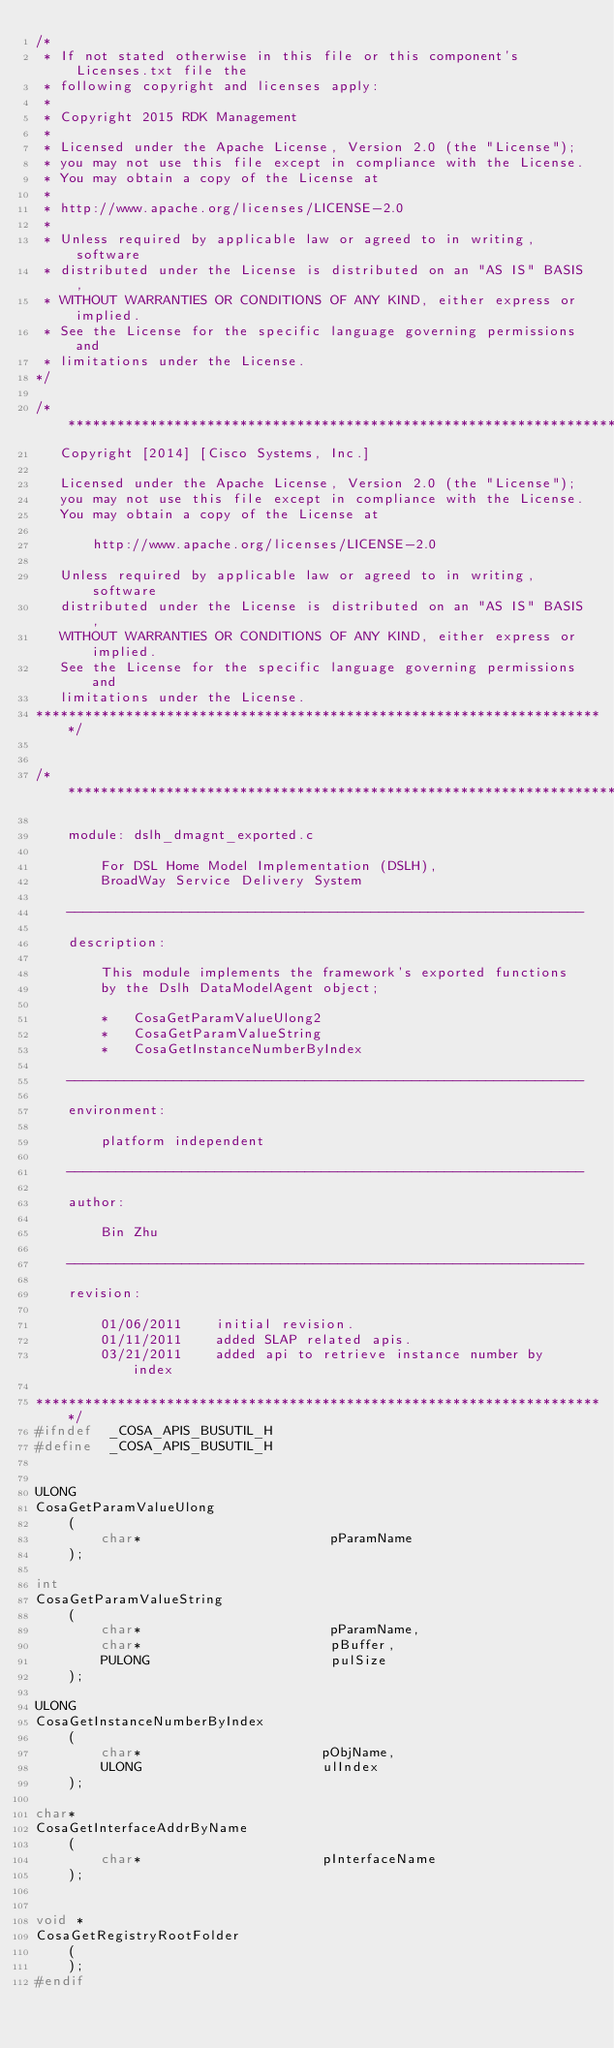Convert code to text. <code><loc_0><loc_0><loc_500><loc_500><_C_>/*
 * If not stated otherwise in this file or this component's Licenses.txt file the
 * following copyright and licenses apply:
 *
 * Copyright 2015 RDK Management
 *
 * Licensed under the Apache License, Version 2.0 (the "License");
 * you may not use this file except in compliance with the License.
 * You may obtain a copy of the License at
 *
 * http://www.apache.org/licenses/LICENSE-2.0
 *
 * Unless required by applicable law or agreed to in writing, software
 * distributed under the License is distributed on an "AS IS" BASIS,
 * WITHOUT WARRANTIES OR CONDITIONS OF ANY KIND, either express or implied.
 * See the License for the specific language governing permissions and
 * limitations under the License.
*/

/**********************************************************************
   Copyright [2014] [Cisco Systems, Inc.]
 
   Licensed under the Apache License, Version 2.0 (the "License");
   you may not use this file except in compliance with the License.
   You may obtain a copy of the License at
 
       http://www.apache.org/licenses/LICENSE-2.0
 
   Unless required by applicable law or agreed to in writing, software
   distributed under the License is distributed on an "AS IS" BASIS,
   WITHOUT WARRANTIES OR CONDITIONS OF ANY KIND, either express or implied.
   See the License for the specific language governing permissions and
   limitations under the License.
**********************************************************************/


/**********************************************************************

    module: dslh_dmagnt_exported.c

        For DSL Home Model Implementation (DSLH),
        BroadWay Service Delivery System

    ---------------------------------------------------------------

    description:

        This module implements the framework's exported functions
        by the Dslh DataModelAgent object;

        *   CosaGetParamValueUlong2
        *   CosaGetParamValueString
        *   CosaGetInstanceNumberByIndex

    ---------------------------------------------------------------

    environment:

        platform independent

    ---------------------------------------------------------------

    author:

        Bin Zhu

    ---------------------------------------------------------------

    revision:

        01/06/2011    initial revision.
        01/11/2011    added SLAP related apis.
        03/21/2011    added api to retrieve instance number by index

**********************************************************************/
#ifndef  _COSA_APIS_BUSUTIL_H
#define  _COSA_APIS_BUSUTIL_H


ULONG
CosaGetParamValueUlong
    (
        char*                       pParamName
    );

int
CosaGetParamValueString
    (
        char*                       pParamName,
        char*                       pBuffer,
        PULONG                      pulSize
    );

ULONG
CosaGetInstanceNumberByIndex
    (
        char*                      pObjName,
        ULONG                      ulIndex
    );

char*
CosaGetInterfaceAddrByName
    (
        char*                      pInterfaceName
    );


void *
CosaGetRegistryRootFolder
    (
    );
#endif
</code> 